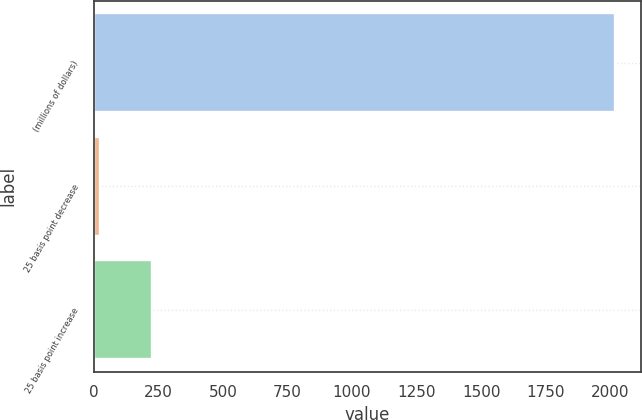<chart> <loc_0><loc_0><loc_500><loc_500><bar_chart><fcel>(millions of dollars)<fcel>25 basis point decrease<fcel>25 basis point increase<nl><fcel>2017<fcel>24.5<fcel>223.75<nl></chart> 